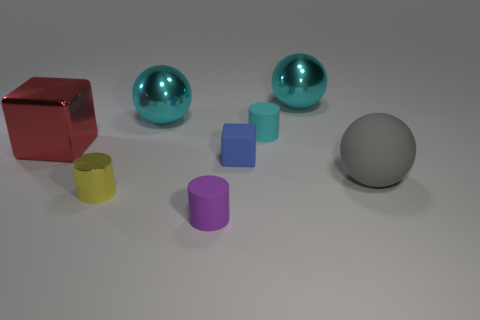Subtract all red cubes. How many cyan balls are left? 2 Add 2 large green matte blocks. How many objects exist? 10 Subtract all shiny cylinders. How many cylinders are left? 2 Subtract 1 cylinders. How many cylinders are left? 2 Subtract all cubes. How many objects are left? 6 Add 1 large spheres. How many large spheres exist? 4 Subtract 0 green blocks. How many objects are left? 8 Subtract all large cyan matte things. Subtract all tiny objects. How many objects are left? 4 Add 7 purple things. How many purple things are left? 8 